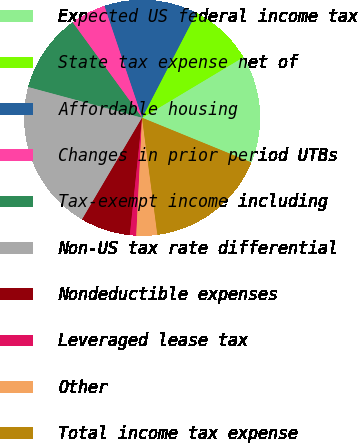Convert chart. <chart><loc_0><loc_0><loc_500><loc_500><pie_chart><fcel>Expected US federal income tax<fcel>State tax expense net of<fcel>Affordable housing<fcel>Changes in prior period UTBs<fcel>Tax-exempt income including<fcel>Non-US tax rate differential<fcel>Nondeductible expenses<fcel>Leveraged lease tax<fcel>Other<fcel>Total income tax expense<nl><fcel>14.76%<fcel>8.81%<fcel>12.78%<fcel>4.84%<fcel>10.79%<fcel>20.71%<fcel>6.83%<fcel>0.87%<fcel>2.86%<fcel>16.75%<nl></chart> 